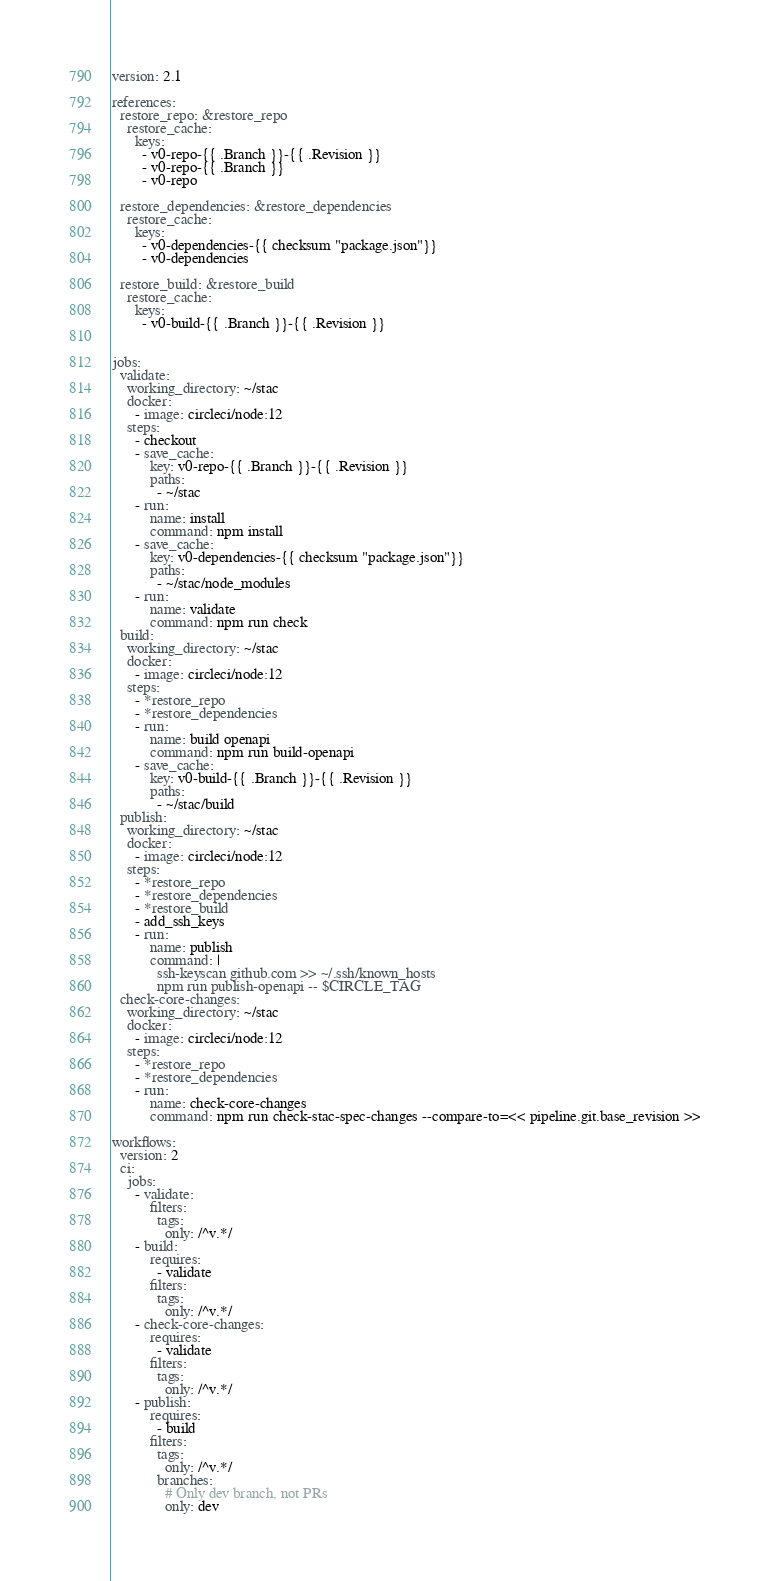<code> <loc_0><loc_0><loc_500><loc_500><_YAML_>version: 2.1

references:
  restore_repo: &restore_repo
    restore_cache:
      keys:
        - v0-repo-{{ .Branch }}-{{ .Revision }}
        - v0-repo-{{ .Branch }}
        - v0-repo

  restore_dependencies: &restore_dependencies
    restore_cache:
      keys: 
        - v0-dependencies-{{ checksum "package.json"}}
        - v0-dependencies

  restore_build: &restore_build
    restore_cache:
      keys: 
        - v0-build-{{ .Branch }}-{{ .Revision }}


jobs:
  validate:
    working_directory: ~/stac
    docker:
      - image: circleci/node:12
    steps:
      - checkout
      - save_cache:
          key: v0-repo-{{ .Branch }}-{{ .Revision }}
          paths:
            - ~/stac
      - run:
          name: install
          command: npm install
      - save_cache:
          key: v0-dependencies-{{ checksum "package.json"}}
          paths:
            - ~/stac/node_modules
      - run:
          name: validate
          command: npm run check
  build:
    working_directory: ~/stac
    docker:
      - image: circleci/node:12
    steps:
      - *restore_repo
      - *restore_dependencies
      - run:
          name: build openapi
          command: npm run build-openapi
      - save_cache:
          key: v0-build-{{ .Branch }}-{{ .Revision }}
          paths:
            - ~/stac/build
  publish:
    working_directory: ~/stac
    docker:
      - image: circleci/node:12
    steps:
      - *restore_repo
      - *restore_dependencies
      - *restore_build
      - add_ssh_keys
      - run:
          name: publish
          command: |
            ssh-keyscan github.com >> ~/.ssh/known_hosts
            npm run publish-openapi -- $CIRCLE_TAG
  check-core-changes:
    working_directory: ~/stac
    docker:
      - image: circleci/node:12
    steps:
      - *restore_repo
      - *restore_dependencies
      - run:
          name: check-core-changes
          command: npm run check-stac-spec-changes --compare-to=<< pipeline.git.base_revision >>

workflows:
  version: 2
  ci:
    jobs:
      - validate:
          filters:
            tags:
              only: /^v.*/
      - build:
          requires:
            - validate
          filters:
            tags:
              only: /^v.*/
      - check-core-changes:
          requires:
            - validate
          filters:
            tags:
              only: /^v.*/
      - publish:
          requires:
            - build
          filters:
            tags:
              only: /^v.*/
            branches:
              # Only dev branch, not PRs
              only: dev</code> 